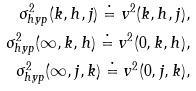<formula> <loc_0><loc_0><loc_500><loc_500>\sigma _ { h y p } ^ { 2 } ( k , h , j ) \doteq v ^ { 2 } ( k , h , j ) , \\ \sigma _ { h y p } ^ { 2 } ( \infty , k , h ) \doteq v ^ { 2 } ( 0 , k , h ) , \\ \sigma _ { h y p } ^ { 2 } ( \infty , j , k ) \doteq v ^ { 2 } ( 0 , j , k ) ,</formula> 